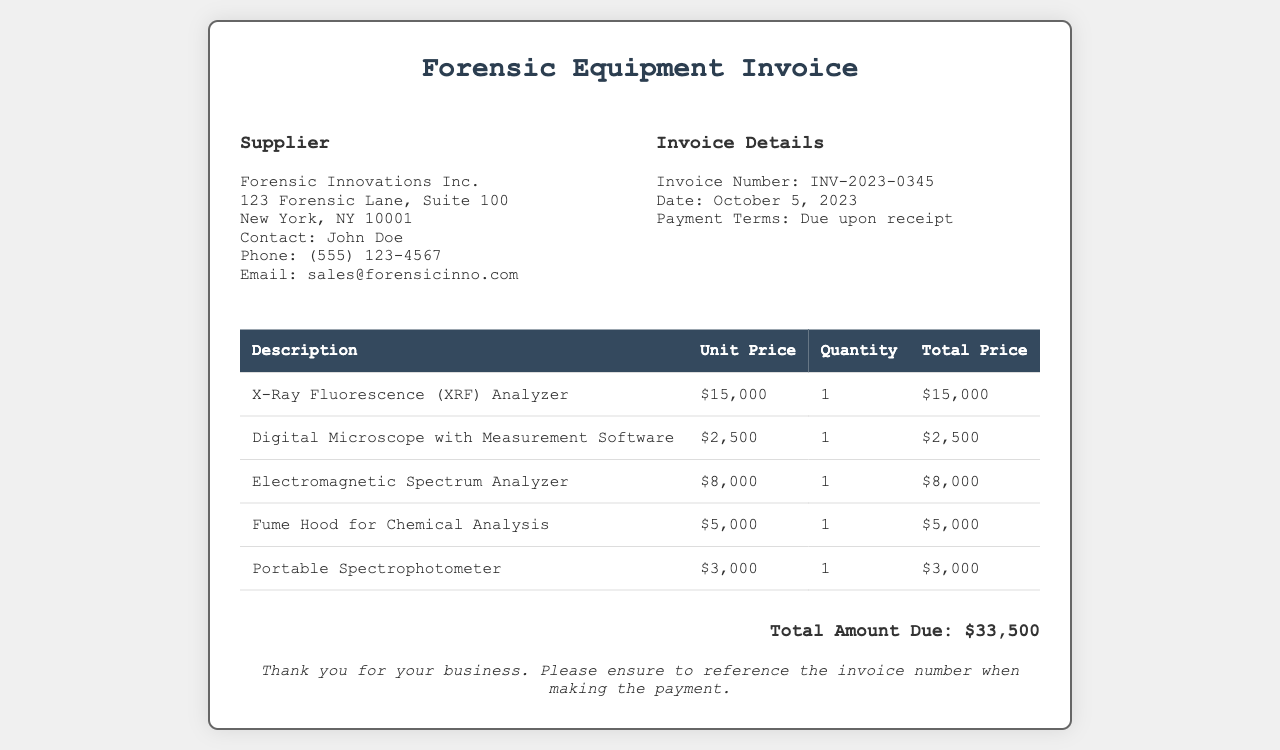What is the name of the supplier? The supplier's name is listed at the top of the document, which is Forensic Innovations Inc.
Answer: Forensic Innovations Inc What is the subtotal for the X-Ray Fluorescence (XRF) Analyzer? The total price for the X-Ray Fluorescence (XRF) Analyzer is given in the invoice table as $15,000.
Answer: $15,000 What is the total amount due? The total amount due is provided at the bottom of the invoice, which sums up all item prices.
Answer: $33,500 When was the invoice issued? The date of issuance is mentioned in the invoice details section, which states October 5, 2023.
Answer: October 5, 2023 What is the unit price of the Digital Microscope? The unit price for the Digital Microscope with Measurement Software is listed in the table as $2,500.
Answer: $2,500 How many items were purchased in total? The invoice lists a total of five items purchased, as seen in the table.
Answer: 5 What is the payment term for this invoice? The payment terms are stated in the invoice details, which specify "Due upon receipt."
Answer: Due upon receipt Which item has the highest unit price? The item with the highest unit price is clearly the X-Ray Fluorescence (XRF) Analyzer at $15,000.
Answer: X-Ray Fluorescence (XRF) Analyzer What additional instruction is mentioned for payment? The note at the bottom of the invoice specifies to reference the invoice number when making the payment.
Answer: Reference the invoice number 